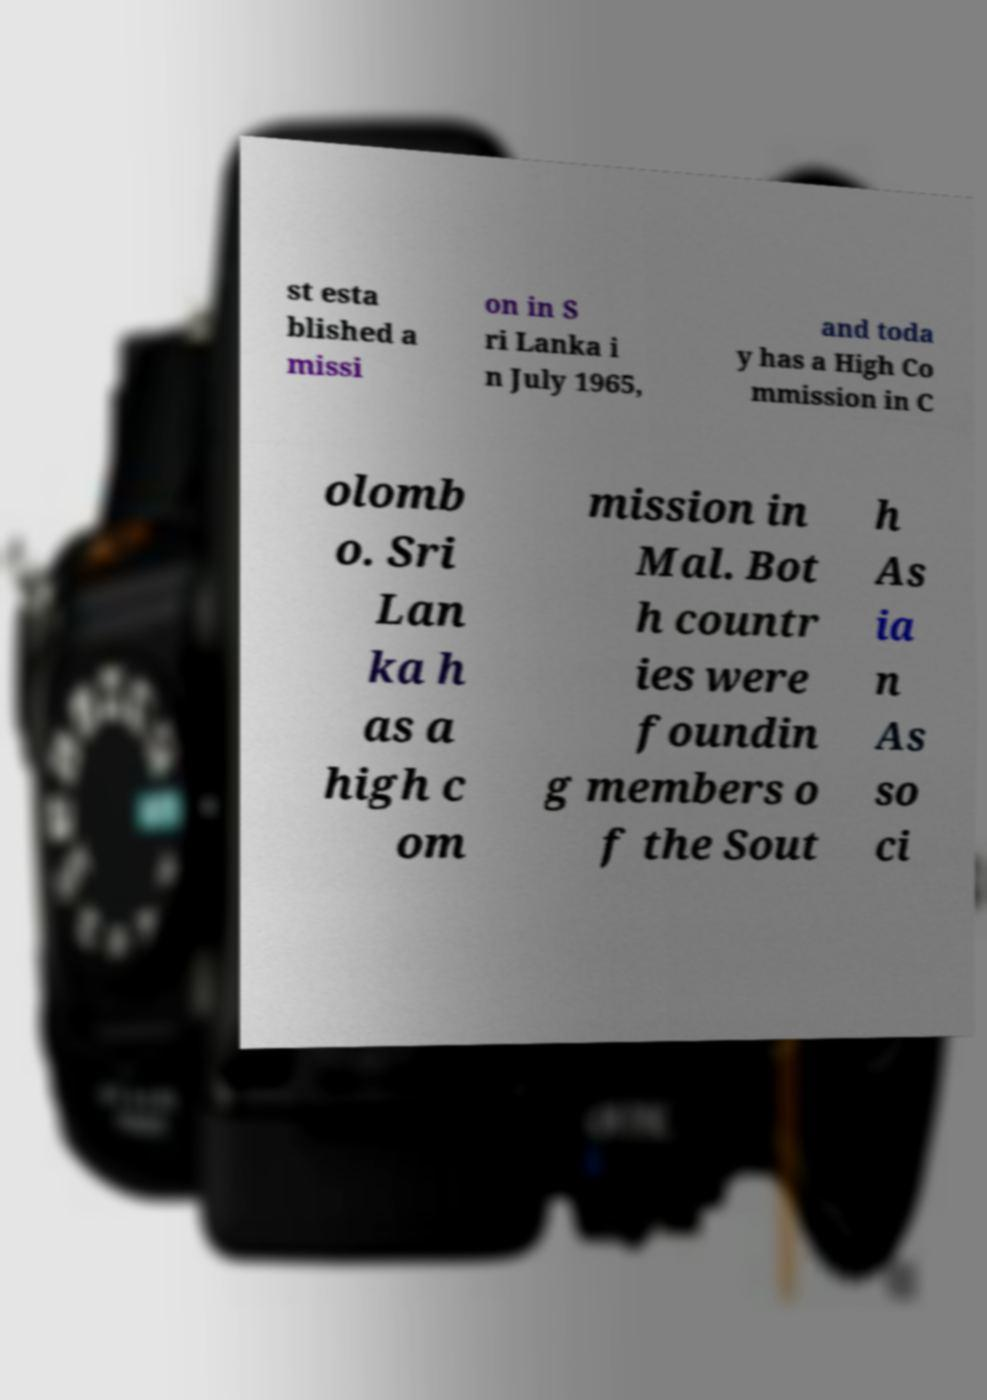I need the written content from this picture converted into text. Can you do that? st esta blished a missi on in S ri Lanka i n July 1965, and toda y has a High Co mmission in C olomb o. Sri Lan ka h as a high c om mission in Mal. Bot h countr ies were foundin g members o f the Sout h As ia n As so ci 